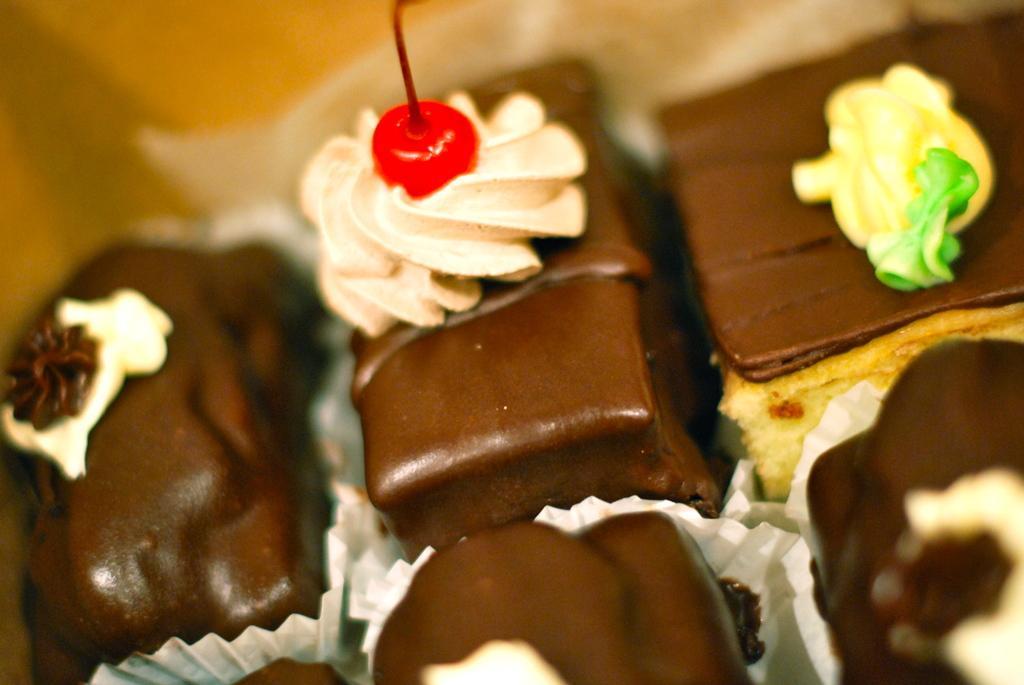Could you give a brief overview of what you see in this image? In this image I can see few cake pieces which are brown, cream, yellow, green and red in color in the paper bowls which are white in color. I can see the blurry background. 